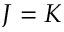<formula> <loc_0><loc_0><loc_500><loc_500>J = K</formula> 